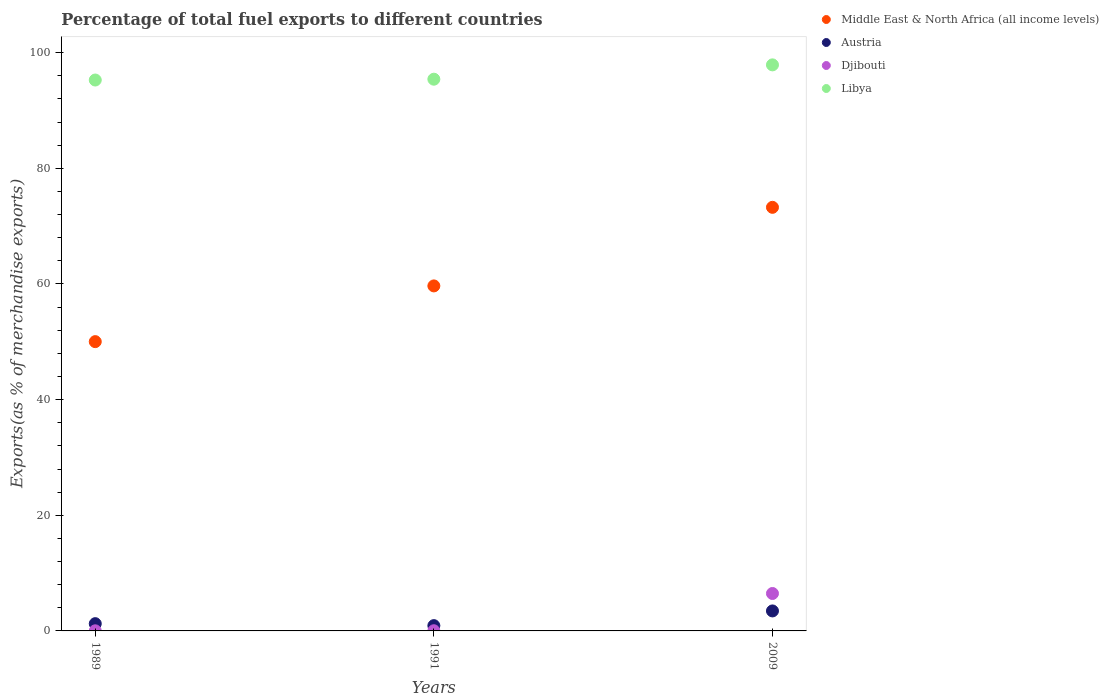How many different coloured dotlines are there?
Your response must be concise. 4. Is the number of dotlines equal to the number of legend labels?
Give a very brief answer. Yes. What is the percentage of exports to different countries in Austria in 2009?
Your response must be concise. 3.46. Across all years, what is the maximum percentage of exports to different countries in Austria?
Your answer should be very brief. 3.46. Across all years, what is the minimum percentage of exports to different countries in Djibouti?
Ensure brevity in your answer.  0.02. What is the total percentage of exports to different countries in Djibouti in the graph?
Provide a succinct answer. 6.52. What is the difference between the percentage of exports to different countries in Middle East & North Africa (all income levels) in 1991 and that in 2009?
Keep it short and to the point. -13.59. What is the difference between the percentage of exports to different countries in Djibouti in 1989 and the percentage of exports to different countries in Middle East & North Africa (all income levels) in 2009?
Offer a very short reply. -73.24. What is the average percentage of exports to different countries in Djibouti per year?
Your response must be concise. 2.17. In the year 1991, what is the difference between the percentage of exports to different countries in Djibouti and percentage of exports to different countries in Libya?
Make the answer very short. -95.39. What is the ratio of the percentage of exports to different countries in Austria in 1991 to that in 2009?
Offer a terse response. 0.26. Is the difference between the percentage of exports to different countries in Djibouti in 1991 and 2009 greater than the difference between the percentage of exports to different countries in Libya in 1991 and 2009?
Provide a succinct answer. No. What is the difference between the highest and the second highest percentage of exports to different countries in Libya?
Ensure brevity in your answer.  2.48. What is the difference between the highest and the lowest percentage of exports to different countries in Middle East & North Africa (all income levels)?
Your answer should be very brief. 23.23. In how many years, is the percentage of exports to different countries in Austria greater than the average percentage of exports to different countries in Austria taken over all years?
Your answer should be very brief. 1. Is the sum of the percentage of exports to different countries in Austria in 1989 and 2009 greater than the maximum percentage of exports to different countries in Djibouti across all years?
Provide a succinct answer. No. Is it the case that in every year, the sum of the percentage of exports to different countries in Libya and percentage of exports to different countries in Djibouti  is greater than the sum of percentage of exports to different countries in Middle East & North Africa (all income levels) and percentage of exports to different countries in Austria?
Provide a succinct answer. No. Is the percentage of exports to different countries in Middle East & North Africa (all income levels) strictly greater than the percentage of exports to different countries in Djibouti over the years?
Provide a succinct answer. Yes. Is the percentage of exports to different countries in Djibouti strictly less than the percentage of exports to different countries in Libya over the years?
Ensure brevity in your answer.  Yes. How many dotlines are there?
Provide a short and direct response. 4. How many years are there in the graph?
Your answer should be very brief. 3. What is the title of the graph?
Your answer should be compact. Percentage of total fuel exports to different countries. What is the label or title of the X-axis?
Provide a succinct answer. Years. What is the label or title of the Y-axis?
Your response must be concise. Exports(as % of merchandise exports). What is the Exports(as % of merchandise exports) of Middle East & North Africa (all income levels) in 1989?
Ensure brevity in your answer.  50.03. What is the Exports(as % of merchandise exports) of Austria in 1989?
Provide a short and direct response. 1.25. What is the Exports(as % of merchandise exports) in Djibouti in 1989?
Offer a very short reply. 0.02. What is the Exports(as % of merchandise exports) in Libya in 1989?
Offer a very short reply. 95.27. What is the Exports(as % of merchandise exports) in Middle East & North Africa (all income levels) in 1991?
Give a very brief answer. 59.67. What is the Exports(as % of merchandise exports) in Austria in 1991?
Your response must be concise. 0.91. What is the Exports(as % of merchandise exports) in Djibouti in 1991?
Your answer should be very brief. 0.03. What is the Exports(as % of merchandise exports) of Libya in 1991?
Your answer should be very brief. 95.42. What is the Exports(as % of merchandise exports) in Middle East & North Africa (all income levels) in 2009?
Give a very brief answer. 73.26. What is the Exports(as % of merchandise exports) in Austria in 2009?
Make the answer very short. 3.46. What is the Exports(as % of merchandise exports) in Djibouti in 2009?
Keep it short and to the point. 6.47. What is the Exports(as % of merchandise exports) of Libya in 2009?
Give a very brief answer. 97.89. Across all years, what is the maximum Exports(as % of merchandise exports) of Middle East & North Africa (all income levels)?
Give a very brief answer. 73.26. Across all years, what is the maximum Exports(as % of merchandise exports) of Austria?
Make the answer very short. 3.46. Across all years, what is the maximum Exports(as % of merchandise exports) in Djibouti?
Your response must be concise. 6.47. Across all years, what is the maximum Exports(as % of merchandise exports) of Libya?
Your response must be concise. 97.89. Across all years, what is the minimum Exports(as % of merchandise exports) of Middle East & North Africa (all income levels)?
Make the answer very short. 50.03. Across all years, what is the minimum Exports(as % of merchandise exports) of Austria?
Ensure brevity in your answer.  0.91. Across all years, what is the minimum Exports(as % of merchandise exports) in Djibouti?
Give a very brief answer. 0.02. Across all years, what is the minimum Exports(as % of merchandise exports) of Libya?
Your answer should be compact. 95.27. What is the total Exports(as % of merchandise exports) in Middle East & North Africa (all income levels) in the graph?
Provide a short and direct response. 182.95. What is the total Exports(as % of merchandise exports) in Austria in the graph?
Your answer should be very brief. 5.63. What is the total Exports(as % of merchandise exports) of Djibouti in the graph?
Provide a succinct answer. 6.52. What is the total Exports(as % of merchandise exports) in Libya in the graph?
Your response must be concise. 288.58. What is the difference between the Exports(as % of merchandise exports) of Middle East & North Africa (all income levels) in 1989 and that in 1991?
Keep it short and to the point. -9.64. What is the difference between the Exports(as % of merchandise exports) of Austria in 1989 and that in 1991?
Your answer should be very brief. 0.34. What is the difference between the Exports(as % of merchandise exports) in Djibouti in 1989 and that in 1991?
Your answer should be very brief. -0.01. What is the difference between the Exports(as % of merchandise exports) in Libya in 1989 and that in 1991?
Keep it short and to the point. -0.14. What is the difference between the Exports(as % of merchandise exports) in Middle East & North Africa (all income levels) in 1989 and that in 2009?
Provide a succinct answer. -23.23. What is the difference between the Exports(as % of merchandise exports) in Austria in 1989 and that in 2009?
Make the answer very short. -2.2. What is the difference between the Exports(as % of merchandise exports) of Djibouti in 1989 and that in 2009?
Provide a succinct answer. -6.45. What is the difference between the Exports(as % of merchandise exports) of Libya in 1989 and that in 2009?
Offer a very short reply. -2.62. What is the difference between the Exports(as % of merchandise exports) of Middle East & North Africa (all income levels) in 1991 and that in 2009?
Provide a short and direct response. -13.59. What is the difference between the Exports(as % of merchandise exports) in Austria in 1991 and that in 2009?
Your response must be concise. -2.54. What is the difference between the Exports(as % of merchandise exports) of Djibouti in 1991 and that in 2009?
Offer a terse response. -6.44. What is the difference between the Exports(as % of merchandise exports) in Libya in 1991 and that in 2009?
Offer a very short reply. -2.48. What is the difference between the Exports(as % of merchandise exports) in Middle East & North Africa (all income levels) in 1989 and the Exports(as % of merchandise exports) in Austria in 1991?
Make the answer very short. 49.12. What is the difference between the Exports(as % of merchandise exports) of Middle East & North Africa (all income levels) in 1989 and the Exports(as % of merchandise exports) of Djibouti in 1991?
Provide a succinct answer. 50. What is the difference between the Exports(as % of merchandise exports) of Middle East & North Africa (all income levels) in 1989 and the Exports(as % of merchandise exports) of Libya in 1991?
Your answer should be compact. -45.39. What is the difference between the Exports(as % of merchandise exports) in Austria in 1989 and the Exports(as % of merchandise exports) in Djibouti in 1991?
Provide a short and direct response. 1.22. What is the difference between the Exports(as % of merchandise exports) of Austria in 1989 and the Exports(as % of merchandise exports) of Libya in 1991?
Provide a short and direct response. -94.16. What is the difference between the Exports(as % of merchandise exports) of Djibouti in 1989 and the Exports(as % of merchandise exports) of Libya in 1991?
Your answer should be compact. -95.39. What is the difference between the Exports(as % of merchandise exports) of Middle East & North Africa (all income levels) in 1989 and the Exports(as % of merchandise exports) of Austria in 2009?
Provide a short and direct response. 46.57. What is the difference between the Exports(as % of merchandise exports) of Middle East & North Africa (all income levels) in 1989 and the Exports(as % of merchandise exports) of Djibouti in 2009?
Your answer should be very brief. 43.56. What is the difference between the Exports(as % of merchandise exports) in Middle East & North Africa (all income levels) in 1989 and the Exports(as % of merchandise exports) in Libya in 2009?
Keep it short and to the point. -47.86. What is the difference between the Exports(as % of merchandise exports) of Austria in 1989 and the Exports(as % of merchandise exports) of Djibouti in 2009?
Give a very brief answer. -5.22. What is the difference between the Exports(as % of merchandise exports) in Austria in 1989 and the Exports(as % of merchandise exports) in Libya in 2009?
Your response must be concise. -96.64. What is the difference between the Exports(as % of merchandise exports) of Djibouti in 1989 and the Exports(as % of merchandise exports) of Libya in 2009?
Provide a succinct answer. -97.87. What is the difference between the Exports(as % of merchandise exports) in Middle East & North Africa (all income levels) in 1991 and the Exports(as % of merchandise exports) in Austria in 2009?
Your answer should be very brief. 56.21. What is the difference between the Exports(as % of merchandise exports) of Middle East & North Africa (all income levels) in 1991 and the Exports(as % of merchandise exports) of Djibouti in 2009?
Provide a succinct answer. 53.19. What is the difference between the Exports(as % of merchandise exports) in Middle East & North Africa (all income levels) in 1991 and the Exports(as % of merchandise exports) in Libya in 2009?
Provide a short and direct response. -38.23. What is the difference between the Exports(as % of merchandise exports) in Austria in 1991 and the Exports(as % of merchandise exports) in Djibouti in 2009?
Offer a very short reply. -5.56. What is the difference between the Exports(as % of merchandise exports) in Austria in 1991 and the Exports(as % of merchandise exports) in Libya in 2009?
Provide a succinct answer. -96.98. What is the difference between the Exports(as % of merchandise exports) in Djibouti in 1991 and the Exports(as % of merchandise exports) in Libya in 2009?
Your response must be concise. -97.86. What is the average Exports(as % of merchandise exports) of Middle East & North Africa (all income levels) per year?
Your response must be concise. 60.98. What is the average Exports(as % of merchandise exports) in Austria per year?
Provide a short and direct response. 1.88. What is the average Exports(as % of merchandise exports) of Djibouti per year?
Make the answer very short. 2.17. What is the average Exports(as % of merchandise exports) in Libya per year?
Provide a succinct answer. 96.19. In the year 1989, what is the difference between the Exports(as % of merchandise exports) of Middle East & North Africa (all income levels) and Exports(as % of merchandise exports) of Austria?
Your response must be concise. 48.77. In the year 1989, what is the difference between the Exports(as % of merchandise exports) of Middle East & North Africa (all income levels) and Exports(as % of merchandise exports) of Djibouti?
Provide a short and direct response. 50.01. In the year 1989, what is the difference between the Exports(as % of merchandise exports) in Middle East & North Africa (all income levels) and Exports(as % of merchandise exports) in Libya?
Keep it short and to the point. -45.24. In the year 1989, what is the difference between the Exports(as % of merchandise exports) in Austria and Exports(as % of merchandise exports) in Djibouti?
Offer a terse response. 1.23. In the year 1989, what is the difference between the Exports(as % of merchandise exports) in Austria and Exports(as % of merchandise exports) in Libya?
Your answer should be very brief. -94.02. In the year 1989, what is the difference between the Exports(as % of merchandise exports) in Djibouti and Exports(as % of merchandise exports) in Libya?
Offer a very short reply. -95.25. In the year 1991, what is the difference between the Exports(as % of merchandise exports) in Middle East & North Africa (all income levels) and Exports(as % of merchandise exports) in Austria?
Give a very brief answer. 58.75. In the year 1991, what is the difference between the Exports(as % of merchandise exports) of Middle East & North Africa (all income levels) and Exports(as % of merchandise exports) of Djibouti?
Offer a very short reply. 59.64. In the year 1991, what is the difference between the Exports(as % of merchandise exports) in Middle East & North Africa (all income levels) and Exports(as % of merchandise exports) in Libya?
Your response must be concise. -35.75. In the year 1991, what is the difference between the Exports(as % of merchandise exports) in Austria and Exports(as % of merchandise exports) in Djibouti?
Provide a succinct answer. 0.88. In the year 1991, what is the difference between the Exports(as % of merchandise exports) in Austria and Exports(as % of merchandise exports) in Libya?
Your answer should be very brief. -94.5. In the year 1991, what is the difference between the Exports(as % of merchandise exports) of Djibouti and Exports(as % of merchandise exports) of Libya?
Ensure brevity in your answer.  -95.39. In the year 2009, what is the difference between the Exports(as % of merchandise exports) in Middle East & North Africa (all income levels) and Exports(as % of merchandise exports) in Austria?
Your answer should be very brief. 69.8. In the year 2009, what is the difference between the Exports(as % of merchandise exports) in Middle East & North Africa (all income levels) and Exports(as % of merchandise exports) in Djibouti?
Provide a short and direct response. 66.78. In the year 2009, what is the difference between the Exports(as % of merchandise exports) in Middle East & North Africa (all income levels) and Exports(as % of merchandise exports) in Libya?
Your response must be concise. -24.64. In the year 2009, what is the difference between the Exports(as % of merchandise exports) in Austria and Exports(as % of merchandise exports) in Djibouti?
Make the answer very short. -3.02. In the year 2009, what is the difference between the Exports(as % of merchandise exports) of Austria and Exports(as % of merchandise exports) of Libya?
Offer a very short reply. -94.44. In the year 2009, what is the difference between the Exports(as % of merchandise exports) of Djibouti and Exports(as % of merchandise exports) of Libya?
Your answer should be compact. -91.42. What is the ratio of the Exports(as % of merchandise exports) in Middle East & North Africa (all income levels) in 1989 to that in 1991?
Your response must be concise. 0.84. What is the ratio of the Exports(as % of merchandise exports) of Austria in 1989 to that in 1991?
Keep it short and to the point. 1.37. What is the ratio of the Exports(as % of merchandise exports) of Djibouti in 1989 to that in 1991?
Your answer should be compact. 0.69. What is the ratio of the Exports(as % of merchandise exports) of Libya in 1989 to that in 1991?
Your answer should be compact. 1. What is the ratio of the Exports(as % of merchandise exports) in Middle East & North Africa (all income levels) in 1989 to that in 2009?
Your answer should be compact. 0.68. What is the ratio of the Exports(as % of merchandise exports) of Austria in 1989 to that in 2009?
Your answer should be very brief. 0.36. What is the ratio of the Exports(as % of merchandise exports) in Djibouti in 1989 to that in 2009?
Keep it short and to the point. 0. What is the ratio of the Exports(as % of merchandise exports) in Libya in 1989 to that in 2009?
Keep it short and to the point. 0.97. What is the ratio of the Exports(as % of merchandise exports) of Middle East & North Africa (all income levels) in 1991 to that in 2009?
Your answer should be very brief. 0.81. What is the ratio of the Exports(as % of merchandise exports) of Austria in 1991 to that in 2009?
Offer a very short reply. 0.26. What is the ratio of the Exports(as % of merchandise exports) in Djibouti in 1991 to that in 2009?
Your answer should be compact. 0. What is the ratio of the Exports(as % of merchandise exports) in Libya in 1991 to that in 2009?
Keep it short and to the point. 0.97. What is the difference between the highest and the second highest Exports(as % of merchandise exports) of Middle East & North Africa (all income levels)?
Keep it short and to the point. 13.59. What is the difference between the highest and the second highest Exports(as % of merchandise exports) in Austria?
Keep it short and to the point. 2.2. What is the difference between the highest and the second highest Exports(as % of merchandise exports) of Djibouti?
Keep it short and to the point. 6.44. What is the difference between the highest and the second highest Exports(as % of merchandise exports) in Libya?
Ensure brevity in your answer.  2.48. What is the difference between the highest and the lowest Exports(as % of merchandise exports) of Middle East & North Africa (all income levels)?
Make the answer very short. 23.23. What is the difference between the highest and the lowest Exports(as % of merchandise exports) of Austria?
Provide a short and direct response. 2.54. What is the difference between the highest and the lowest Exports(as % of merchandise exports) of Djibouti?
Keep it short and to the point. 6.45. What is the difference between the highest and the lowest Exports(as % of merchandise exports) in Libya?
Offer a terse response. 2.62. 